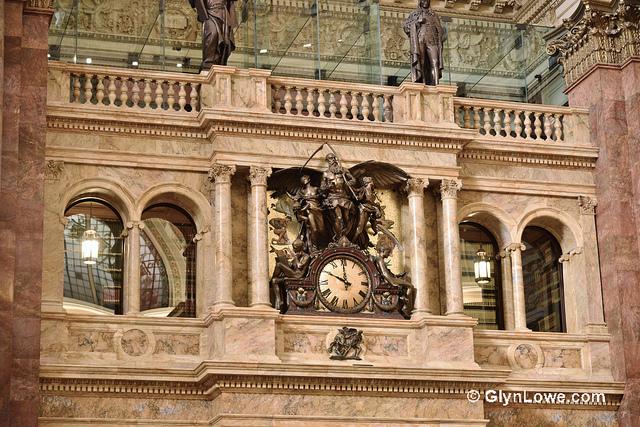How many arches are in the building?
Give a very brief answer. 4. What is the architectural style depicted?
Be succinct. Gothic. What metal is found detailing this building?
Be succinct. Bronze. Where is the clock?
Quick response, please. Middle. 